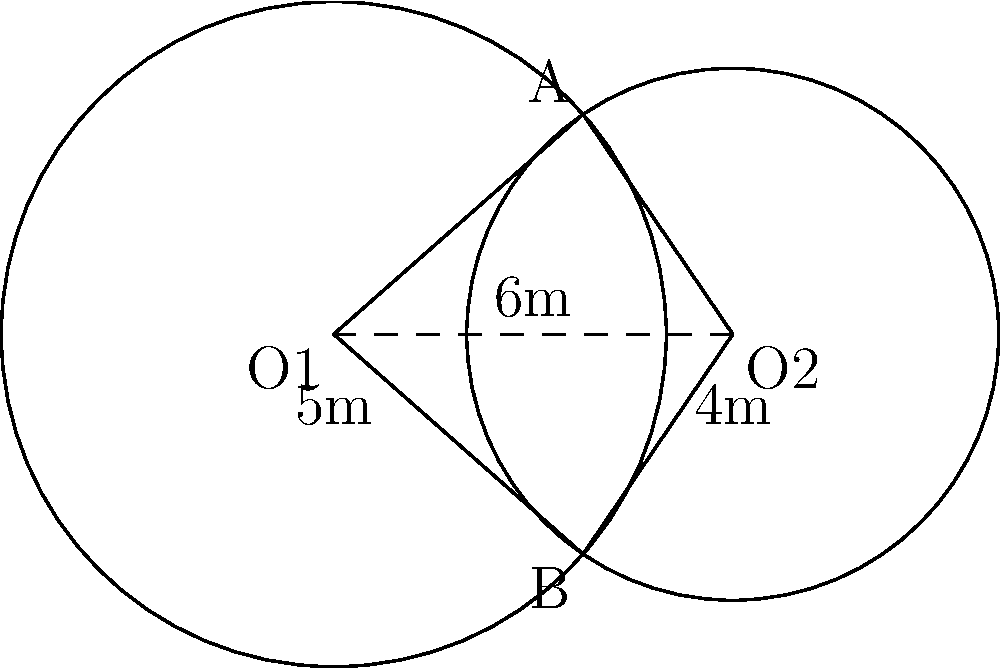Two circular scent diffusion areas overlap as shown in the diagram. The radius of the larger circle centered at O1 is 5m, and the radius of the smaller circle centered at O2 is 4m. The distance between the centers is 6m. Calculate the area of the overlapping region (shaded area) where both scents are present. To find the area of the overlapping region, we'll use the formula for the area of intersection of two circles:

1) First, calculate the central angle $\theta$ for each circle:
   
   $\cos(\frac{\theta_1}{2}) = \frac{6^2 + 5^2 - 4^2}{2 \cdot 6 \cdot 5} = \frac{61}{60}$
   $\theta_1 = 2 \arccos(\frac{61}{60}) = 0.5904$ radians
   
   $\cos(\frac{\theta_2}{2}) = \frac{6^2 + 4^2 - 5^2}{2 \cdot 6 \cdot 4} = \frac{11}{16}$
   $\theta_2 = 2 \arccos(\frac{11}{16}) = 2.2143$ radians

2) Calculate the areas of the circular sectors:
   
   $A_1 = \frac{1}{2} \cdot 5^2 \cdot 0.5904 = 7.3800$ m²
   $A_2 = \frac{1}{2} \cdot 4^2 \cdot 2.2143 = 17.7144$ m²

3) Calculate the areas of the triangles:
   
   $A_{triangle1} = \frac{1}{2} \cdot 5 \cdot 5 \cdot \sin(0.5904) = 7.0711$ m²
   $A_{triangle2} = \frac{1}{2} \cdot 4 \cdot 4 \cdot \sin(2.2143) = 7.0711$ m²

4) The area of intersection is the sum of the sectors minus the sum of the triangles:
   
   $A_{intersection} = (A_1 + A_2) - (A_{triangle1} + A_{triangle2})$
   $A_{intersection} = (7.3800 + 17.7144) - (7.0711 + 7.0711)$
   $A_{intersection} = 25.0944 - 14.1422 = 10.9522$ m²

Therefore, the area of the overlapping region is approximately 10.9522 m².
Answer: 10.9522 m² 